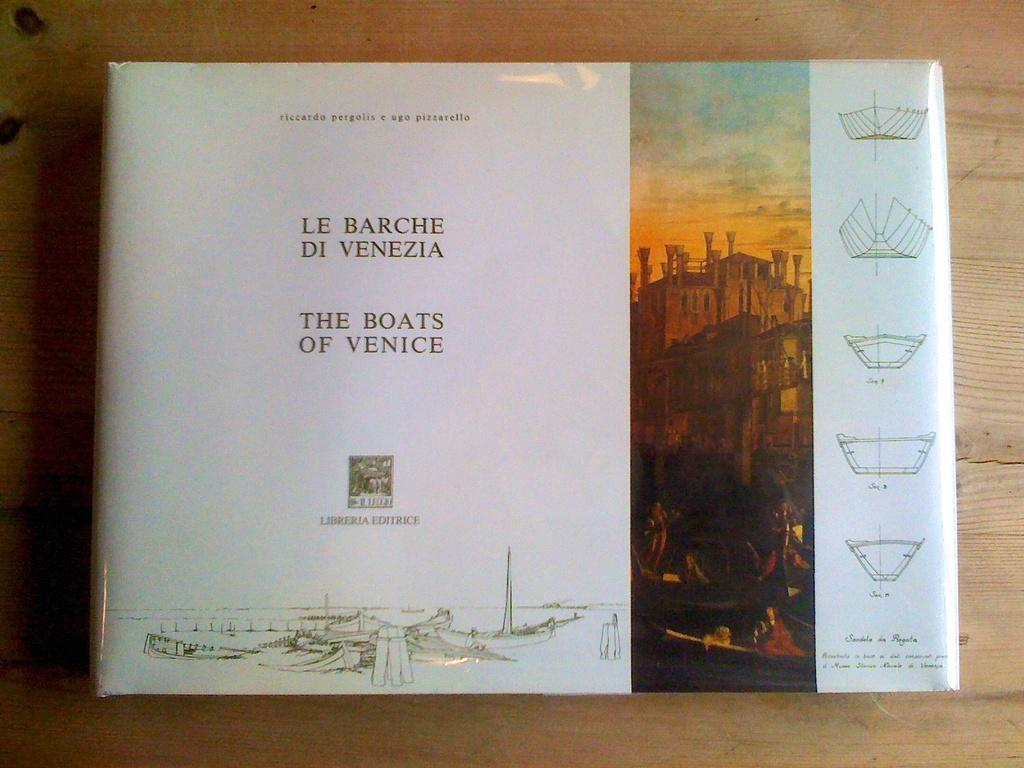<image>
Create a compact narrative representing the image presented. A book displays its title, The Boats of Venice, in English and Italian. 